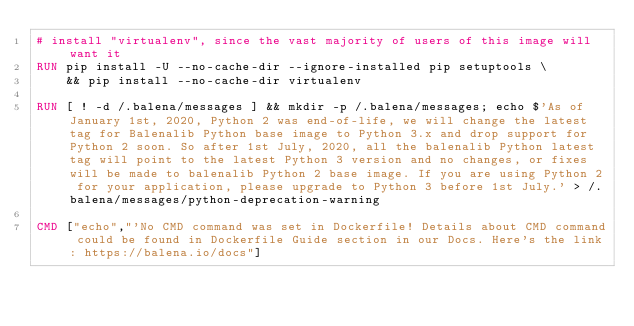Convert code to text. <code><loc_0><loc_0><loc_500><loc_500><_Dockerfile_># install "virtualenv", since the vast majority of users of this image will want it
RUN pip install -U --no-cache-dir --ignore-installed pip setuptools \
	&& pip install --no-cache-dir virtualenv

RUN [ ! -d /.balena/messages ] && mkdir -p /.balena/messages; echo $'As of January 1st, 2020, Python 2 was end-of-life, we will change the latest tag for Balenalib Python base image to Python 3.x and drop support for Python 2 soon. So after 1st July, 2020, all the balenalib Python latest tag will point to the latest Python 3 version and no changes, or fixes will be made to balenalib Python 2 base image. If you are using Python 2 for your application, please upgrade to Python 3 before 1st July.' > /.balena/messages/python-deprecation-warning

CMD ["echo","'No CMD command was set in Dockerfile! Details about CMD command could be found in Dockerfile Guide section in our Docs. Here's the link: https://balena.io/docs"]
</code> 